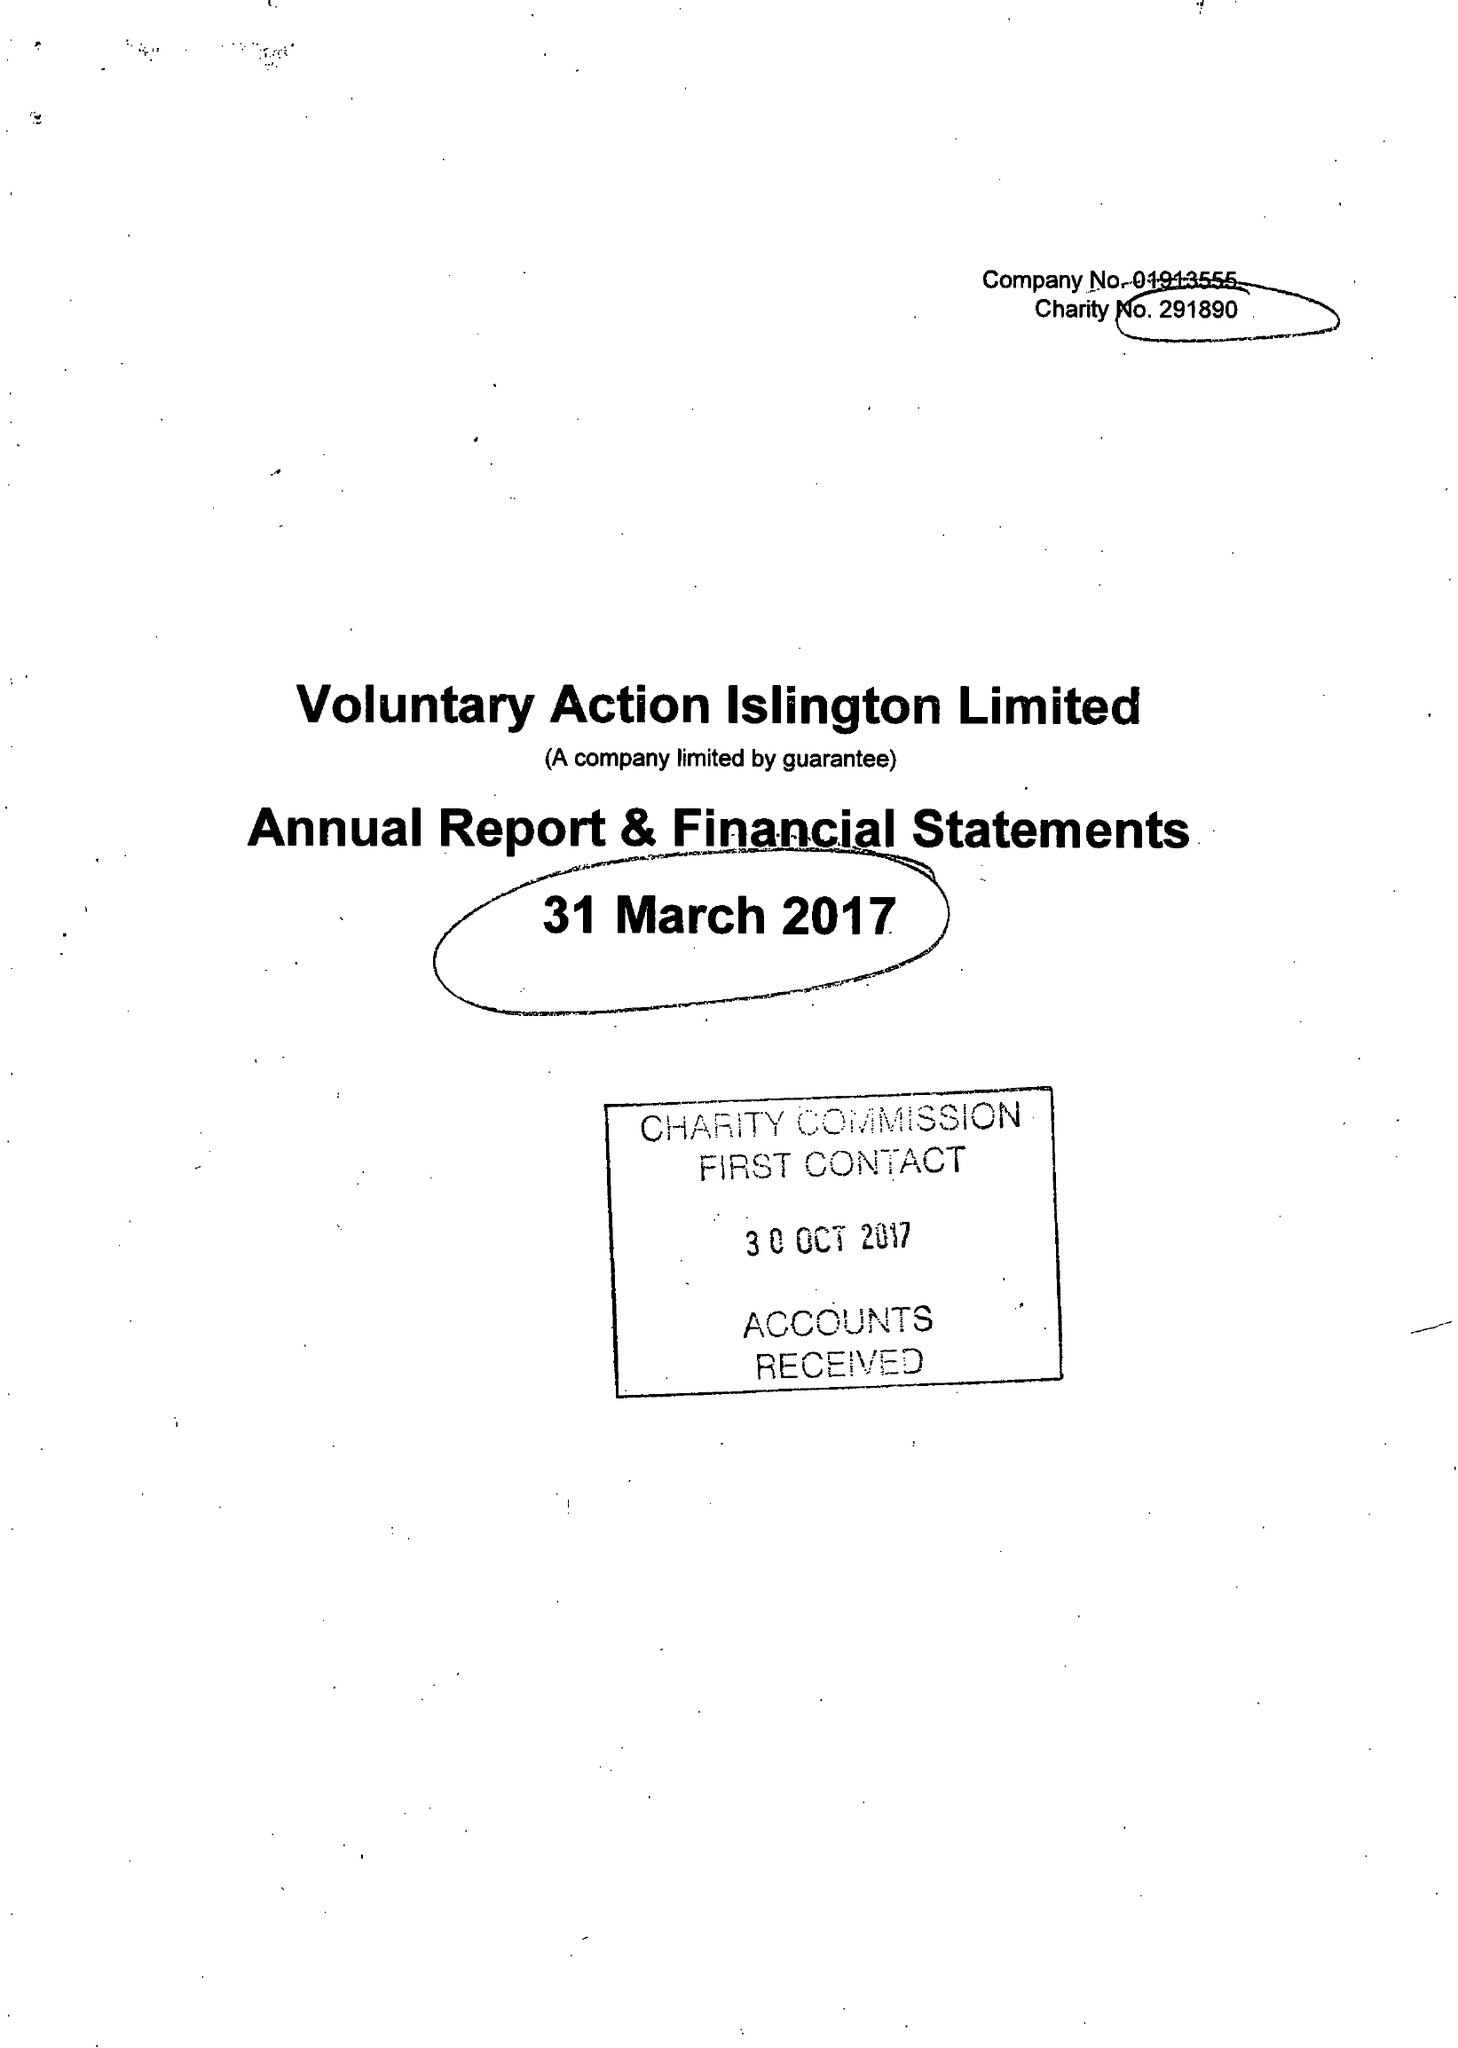What is the value for the charity_number?
Answer the question using a single word or phrase. 291890 